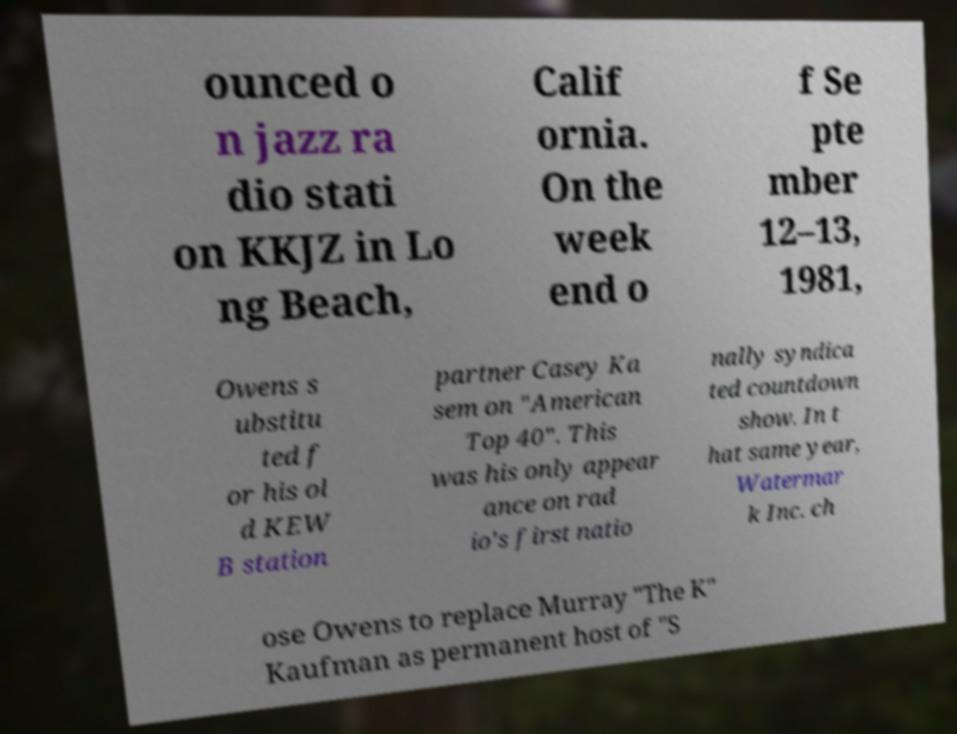Please identify and transcribe the text found in this image. ounced o n jazz ra dio stati on KKJZ in Lo ng Beach, Calif ornia. On the week end o f Se pte mber 12–13, 1981, Owens s ubstitu ted f or his ol d KEW B station partner Casey Ka sem on "American Top 40". This was his only appear ance on rad io's first natio nally syndica ted countdown show. In t hat same year, Watermar k Inc. ch ose Owens to replace Murray "The K" Kaufman as permanent host of "S 